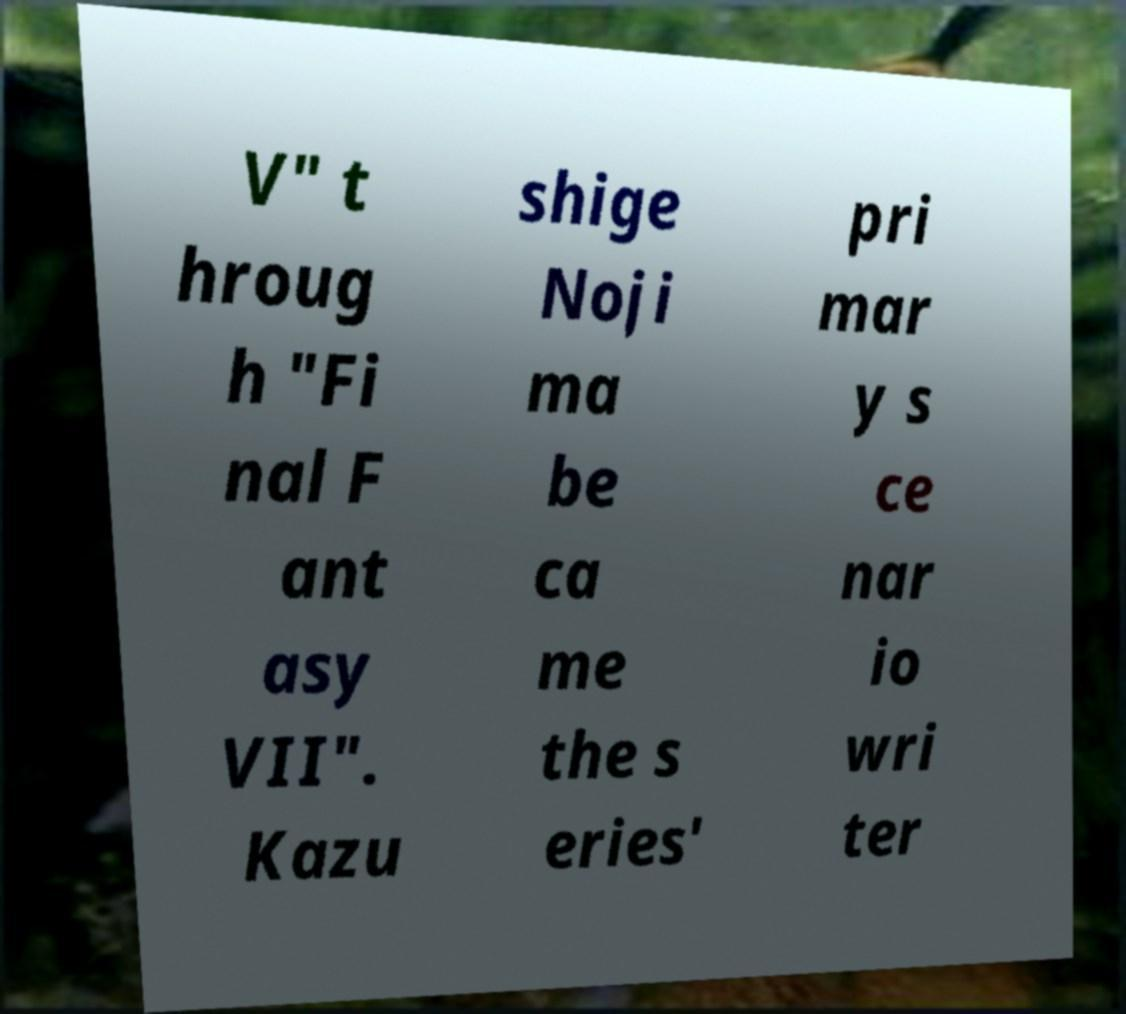Could you assist in decoding the text presented in this image and type it out clearly? V" t hroug h "Fi nal F ant asy VII". Kazu shige Noji ma be ca me the s eries' pri mar y s ce nar io wri ter 